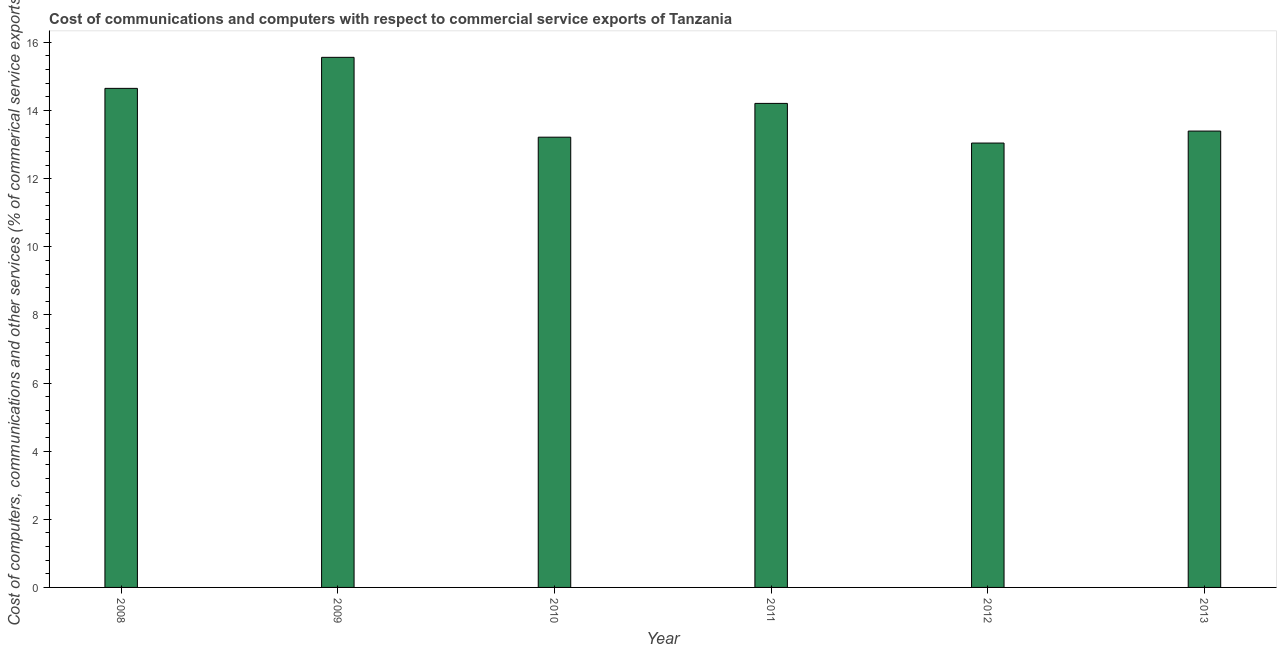What is the title of the graph?
Offer a very short reply. Cost of communications and computers with respect to commercial service exports of Tanzania. What is the label or title of the Y-axis?
Ensure brevity in your answer.  Cost of computers, communications and other services (% of commerical service exports). What is the  computer and other services in 2011?
Your response must be concise. 14.21. Across all years, what is the maximum  computer and other services?
Your answer should be compact. 15.56. Across all years, what is the minimum  computer and other services?
Provide a short and direct response. 13.04. In which year was the cost of communications maximum?
Your answer should be compact. 2009. In which year was the cost of communications minimum?
Keep it short and to the point. 2012. What is the sum of the  computer and other services?
Offer a very short reply. 84.08. What is the difference between the  computer and other services in 2008 and 2011?
Keep it short and to the point. 0.44. What is the average  computer and other services per year?
Provide a short and direct response. 14.01. What is the median  computer and other services?
Your answer should be compact. 13.8. In how many years, is the cost of communications greater than 11.2 %?
Give a very brief answer. 6. What is the ratio of the cost of communications in 2009 to that in 2011?
Give a very brief answer. 1.09. Is the  computer and other services in 2010 less than that in 2011?
Ensure brevity in your answer.  Yes. Is the difference between the cost of communications in 2009 and 2010 greater than the difference between any two years?
Provide a succinct answer. No. What is the difference between the highest and the second highest cost of communications?
Provide a short and direct response. 0.91. What is the difference between the highest and the lowest  computer and other services?
Ensure brevity in your answer.  2.52. In how many years, is the  computer and other services greater than the average  computer and other services taken over all years?
Your answer should be compact. 3. How many bars are there?
Make the answer very short. 6. How many years are there in the graph?
Give a very brief answer. 6. What is the Cost of computers, communications and other services (% of commerical service exports) of 2008?
Provide a succinct answer. 14.65. What is the Cost of computers, communications and other services (% of commerical service exports) in 2009?
Offer a terse response. 15.56. What is the Cost of computers, communications and other services (% of commerical service exports) in 2010?
Your response must be concise. 13.22. What is the Cost of computers, communications and other services (% of commerical service exports) in 2011?
Ensure brevity in your answer.  14.21. What is the Cost of computers, communications and other services (% of commerical service exports) in 2012?
Provide a succinct answer. 13.04. What is the Cost of computers, communications and other services (% of commerical service exports) of 2013?
Provide a short and direct response. 13.4. What is the difference between the Cost of computers, communications and other services (% of commerical service exports) in 2008 and 2009?
Your answer should be compact. -0.91. What is the difference between the Cost of computers, communications and other services (% of commerical service exports) in 2008 and 2010?
Offer a very short reply. 1.43. What is the difference between the Cost of computers, communications and other services (% of commerical service exports) in 2008 and 2011?
Keep it short and to the point. 0.44. What is the difference between the Cost of computers, communications and other services (% of commerical service exports) in 2008 and 2012?
Provide a succinct answer. 1.61. What is the difference between the Cost of computers, communications and other services (% of commerical service exports) in 2008 and 2013?
Your answer should be very brief. 1.25. What is the difference between the Cost of computers, communications and other services (% of commerical service exports) in 2009 and 2010?
Offer a very short reply. 2.34. What is the difference between the Cost of computers, communications and other services (% of commerical service exports) in 2009 and 2011?
Offer a terse response. 1.35. What is the difference between the Cost of computers, communications and other services (% of commerical service exports) in 2009 and 2012?
Provide a succinct answer. 2.52. What is the difference between the Cost of computers, communications and other services (% of commerical service exports) in 2009 and 2013?
Provide a short and direct response. 2.16. What is the difference between the Cost of computers, communications and other services (% of commerical service exports) in 2010 and 2011?
Provide a short and direct response. -0.99. What is the difference between the Cost of computers, communications and other services (% of commerical service exports) in 2010 and 2012?
Provide a short and direct response. 0.17. What is the difference between the Cost of computers, communications and other services (% of commerical service exports) in 2010 and 2013?
Your answer should be very brief. -0.18. What is the difference between the Cost of computers, communications and other services (% of commerical service exports) in 2011 and 2012?
Your response must be concise. 1.16. What is the difference between the Cost of computers, communications and other services (% of commerical service exports) in 2011 and 2013?
Your answer should be very brief. 0.81. What is the difference between the Cost of computers, communications and other services (% of commerical service exports) in 2012 and 2013?
Provide a succinct answer. -0.35. What is the ratio of the Cost of computers, communications and other services (% of commerical service exports) in 2008 to that in 2009?
Provide a short and direct response. 0.94. What is the ratio of the Cost of computers, communications and other services (% of commerical service exports) in 2008 to that in 2010?
Keep it short and to the point. 1.11. What is the ratio of the Cost of computers, communications and other services (% of commerical service exports) in 2008 to that in 2011?
Give a very brief answer. 1.03. What is the ratio of the Cost of computers, communications and other services (% of commerical service exports) in 2008 to that in 2012?
Your answer should be very brief. 1.12. What is the ratio of the Cost of computers, communications and other services (% of commerical service exports) in 2008 to that in 2013?
Give a very brief answer. 1.09. What is the ratio of the Cost of computers, communications and other services (% of commerical service exports) in 2009 to that in 2010?
Make the answer very short. 1.18. What is the ratio of the Cost of computers, communications and other services (% of commerical service exports) in 2009 to that in 2011?
Make the answer very short. 1.09. What is the ratio of the Cost of computers, communications and other services (% of commerical service exports) in 2009 to that in 2012?
Provide a succinct answer. 1.19. What is the ratio of the Cost of computers, communications and other services (% of commerical service exports) in 2009 to that in 2013?
Offer a very short reply. 1.16. What is the ratio of the Cost of computers, communications and other services (% of commerical service exports) in 2010 to that in 2012?
Offer a terse response. 1.01. What is the ratio of the Cost of computers, communications and other services (% of commerical service exports) in 2010 to that in 2013?
Give a very brief answer. 0.99. What is the ratio of the Cost of computers, communications and other services (% of commerical service exports) in 2011 to that in 2012?
Make the answer very short. 1.09. What is the ratio of the Cost of computers, communications and other services (% of commerical service exports) in 2011 to that in 2013?
Provide a succinct answer. 1.06. What is the ratio of the Cost of computers, communications and other services (% of commerical service exports) in 2012 to that in 2013?
Give a very brief answer. 0.97. 